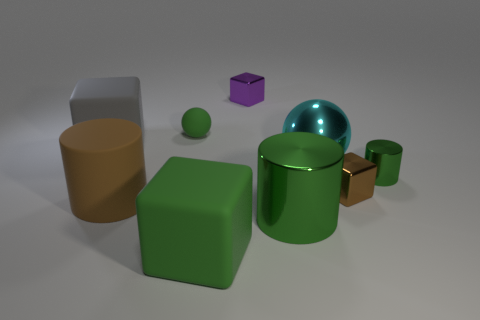Subtract 2 cubes. How many cubes are left? 2 Subtract all brown blocks. How many blocks are left? 3 Subtract all purple blocks. How many blocks are left? 3 Subtract all yellow cubes. Subtract all yellow cylinders. How many cubes are left? 4 Add 1 gray matte cubes. How many objects exist? 10 Subtract all spheres. How many objects are left? 7 Add 5 small purple things. How many small purple things exist? 6 Subtract 1 green cubes. How many objects are left? 8 Subtract all cylinders. Subtract all tiny metal blocks. How many objects are left? 4 Add 4 gray rubber cubes. How many gray rubber cubes are left? 5 